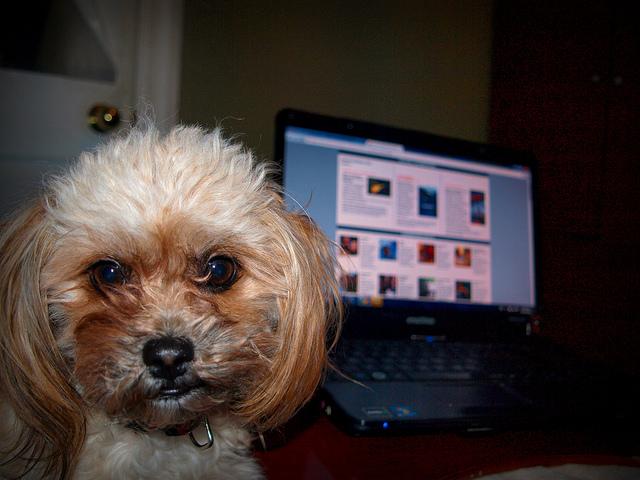What is the dog holding in its mouth?
Keep it brief. Nothing. Is the laptop using OS X, Windows, or Linux?
Quick response, please. Windows. What color is the dog?
Write a very short answer. Brown. What kind of dog is shown?
Answer briefly. Poodle. Has this dog been groomed recently?
Short answer required. Yes. What is the dog looking at?
Quick response, please. Camera. 